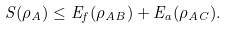<formula> <loc_0><loc_0><loc_500><loc_500>S ( \rho _ { A } ) \leq E _ { f } ( \rho _ { A B } ) + E _ { a } ( \rho _ { A C } ) .</formula> 